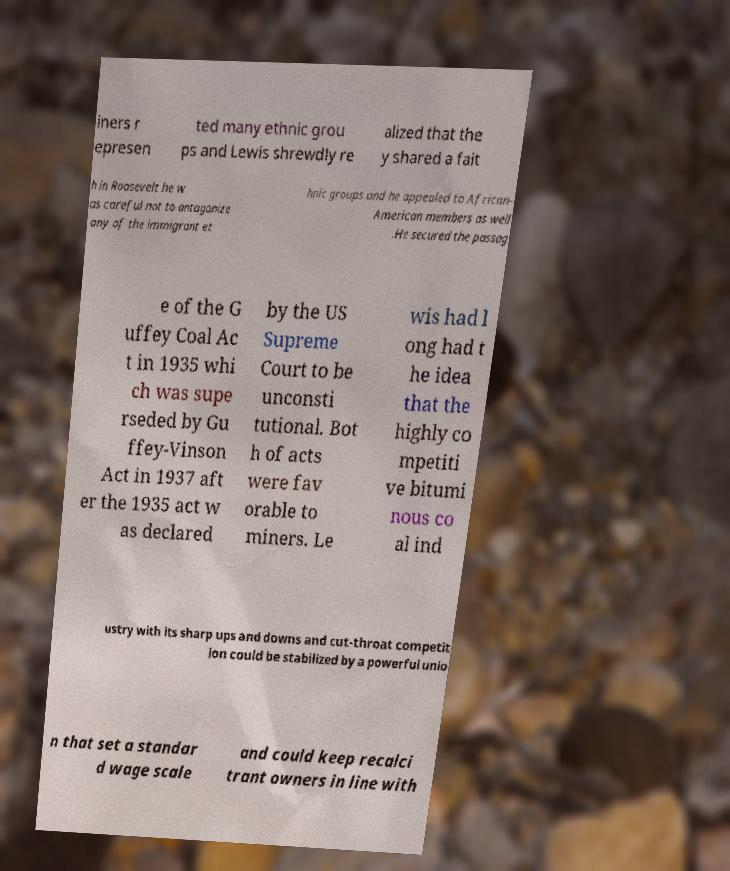Can you accurately transcribe the text from the provided image for me? iners r epresen ted many ethnic grou ps and Lewis shrewdly re alized that the y shared a fait h in Roosevelt he w as careful not to antagonize any of the immigrant et hnic groups and he appealed to African- American members as well .He secured the passag e of the G uffey Coal Ac t in 1935 whi ch was supe rseded by Gu ffey-Vinson Act in 1937 aft er the 1935 act w as declared by the US Supreme Court to be unconsti tutional. Bot h of acts were fav orable to miners. Le wis had l ong had t he idea that the highly co mpetiti ve bitumi nous co al ind ustry with its sharp ups and downs and cut-throat competit ion could be stabilized by a powerful unio n that set a standar d wage scale and could keep recalci trant owners in line with 